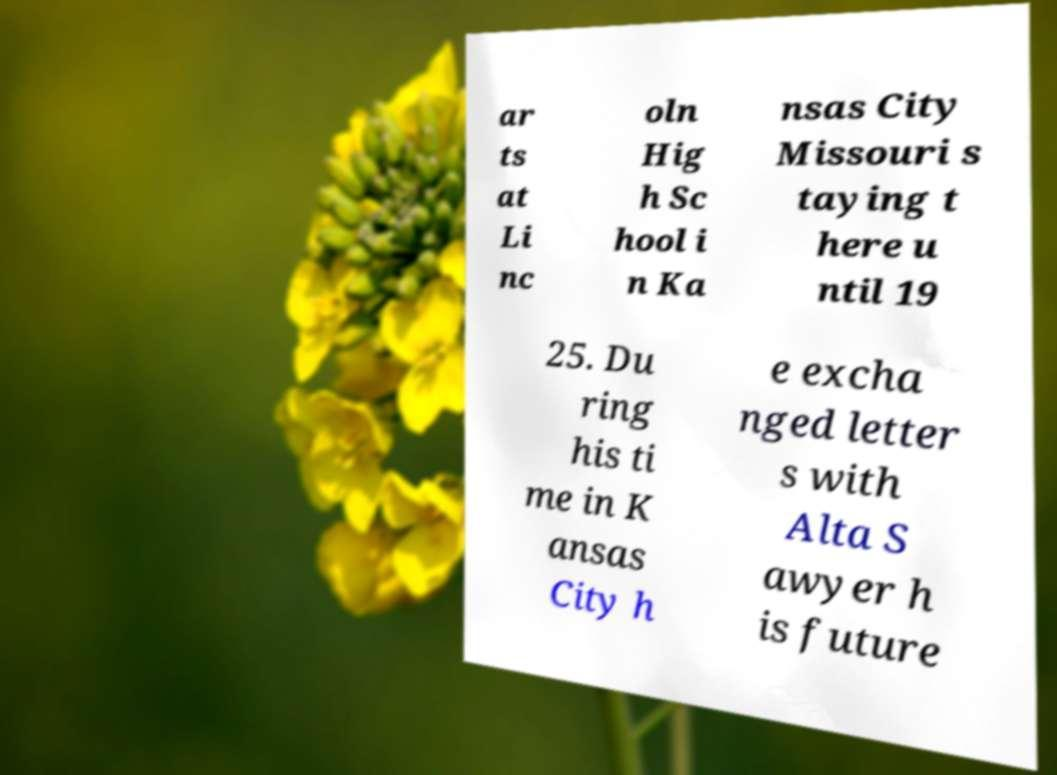Can you accurately transcribe the text from the provided image for me? ar ts at Li nc oln Hig h Sc hool i n Ka nsas City Missouri s taying t here u ntil 19 25. Du ring his ti me in K ansas City h e excha nged letter s with Alta S awyer h is future 